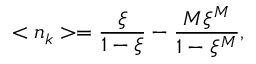<formula> <loc_0><loc_0><loc_500><loc_500>< n _ { k } > = \frac { \xi } { 1 - \xi } - \frac { M \xi ^ { M } } { 1 - \xi ^ { M } } ,</formula> 